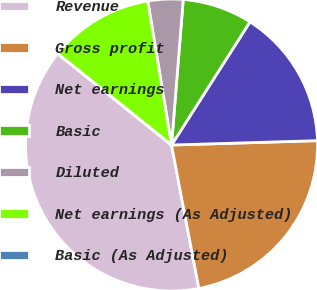<chart> <loc_0><loc_0><loc_500><loc_500><pie_chart><fcel>Revenue<fcel>Gross profit<fcel>Net earnings<fcel>Basic<fcel>Diluted<fcel>Net earnings (As Adjusted)<fcel>Basic (As Adjusted)<nl><fcel>38.76%<fcel>22.48%<fcel>15.5%<fcel>7.75%<fcel>3.88%<fcel>11.63%<fcel>0.0%<nl></chart> 